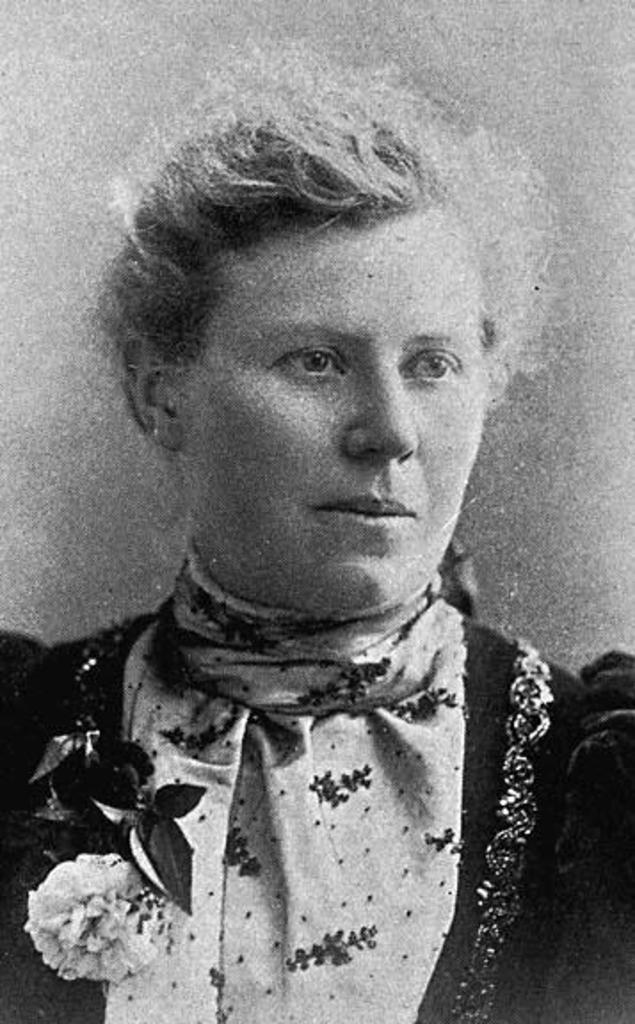What type of image is present in the picture? There is an old black and white photo in the image. Can you describe the content of the photo? There is a woman in the photo. What type of rake is being used to clean the nation in the image? There is no rake or nation present in the image; it only features an old black and white photo of a woman. 